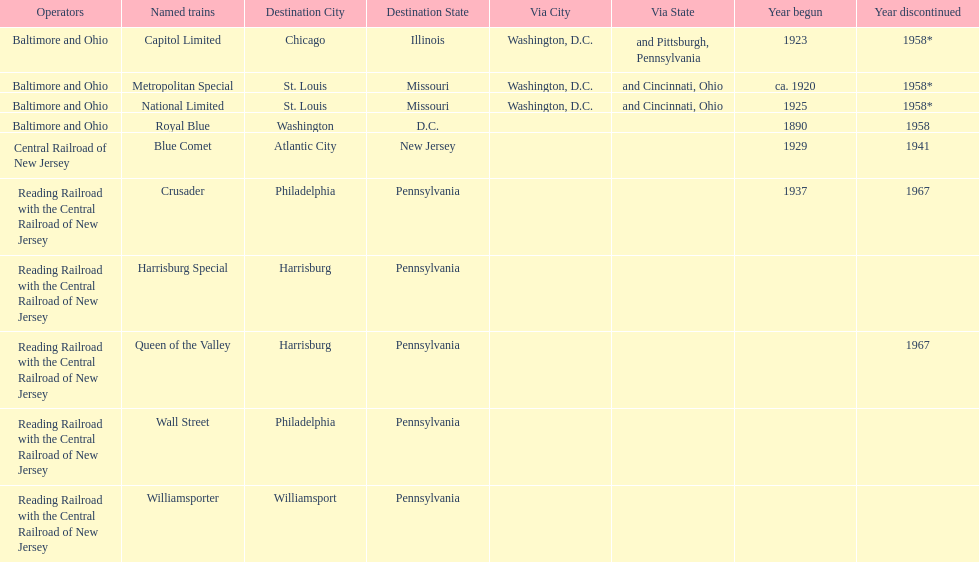What is the total number of year begun? 6. Write the full table. {'header': ['Operators', 'Named trains', 'Destination City', 'Destination State', 'Via City', 'Via State', 'Year begun', 'Year discontinued'], 'rows': [['Baltimore and Ohio', 'Capitol Limited', 'Chicago', 'Illinois', 'Washington, D.C.', 'and Pittsburgh, Pennsylvania', '1923', '1958*'], ['Baltimore and Ohio', 'Metropolitan Special', 'St. Louis', 'Missouri', 'Washington, D.C.', 'and Cincinnati, Ohio', 'ca. 1920', '1958*'], ['Baltimore and Ohio', 'National Limited', 'St. Louis', 'Missouri', 'Washington, D.C.', 'and Cincinnati, Ohio', '1925', '1958*'], ['Baltimore and Ohio', 'Royal Blue', 'Washington', 'D.C.', '', '', '1890', '1958'], ['Central Railroad of New Jersey', 'Blue Comet', 'Atlantic City', 'New Jersey', '', '', '1929', '1941'], ['Reading Railroad with the Central Railroad of New Jersey', 'Crusader', 'Philadelphia', 'Pennsylvania', '', '', '1937', '1967'], ['Reading Railroad with the Central Railroad of New Jersey', 'Harrisburg Special', 'Harrisburg', 'Pennsylvania', '', '', '', ''], ['Reading Railroad with the Central Railroad of New Jersey', 'Queen of the Valley', 'Harrisburg', 'Pennsylvania', '', '', '', '1967'], ['Reading Railroad with the Central Railroad of New Jersey', 'Wall Street', 'Philadelphia', 'Pennsylvania', '', '', '', ''], ['Reading Railroad with the Central Railroad of New Jersey', 'Williamsporter', 'Williamsport', 'Pennsylvania', '', '', '', '']]} 